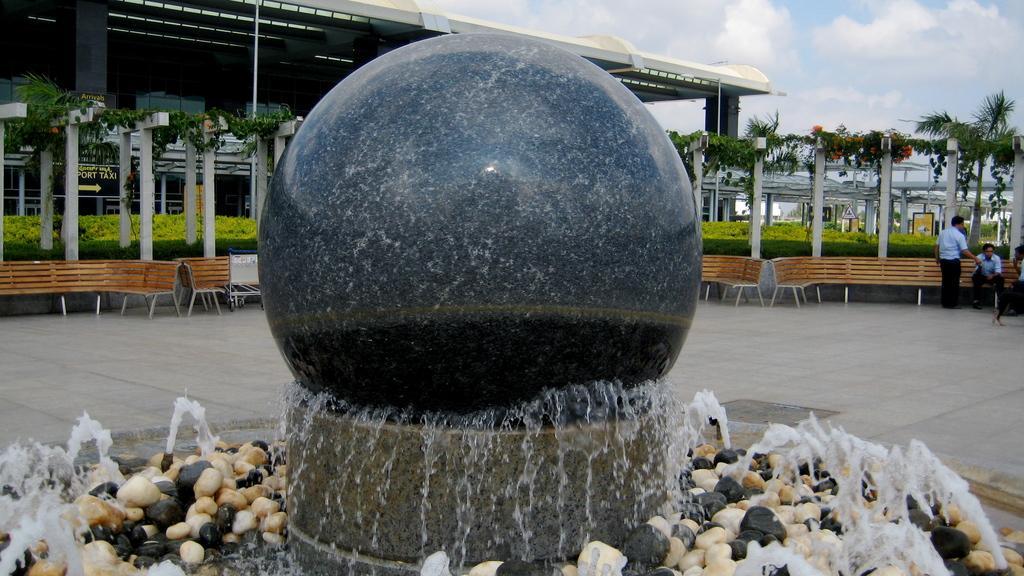In one or two sentences, can you explain what this image depicts? Sky is cloudy. Background there is a building, tree, plants and benches. Here we can see two people. From we can see water fountain with rocks. 